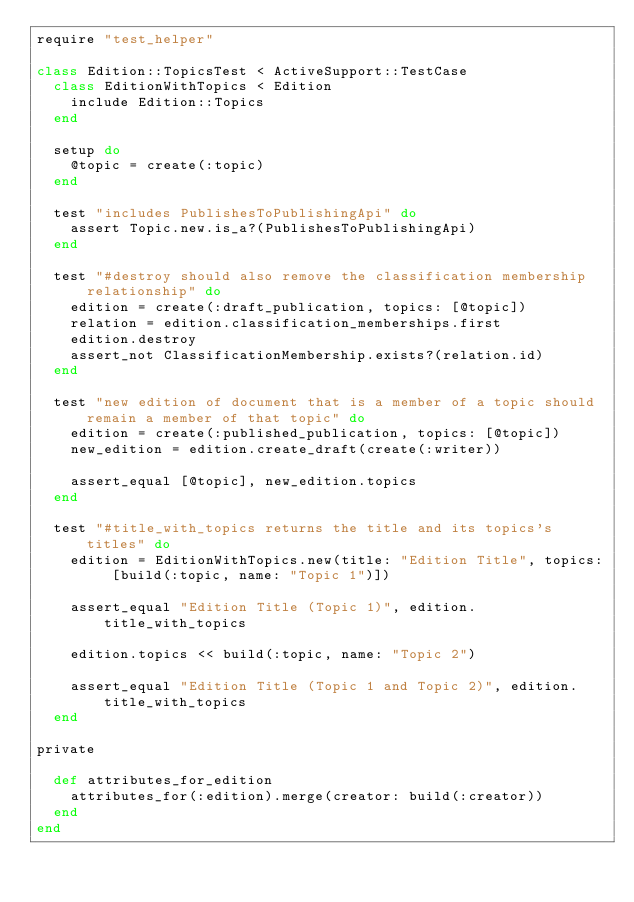<code> <loc_0><loc_0><loc_500><loc_500><_Ruby_>require "test_helper"

class Edition::TopicsTest < ActiveSupport::TestCase
  class EditionWithTopics < Edition
    include Edition::Topics
  end

  setup do
    @topic = create(:topic)
  end

  test "includes PublishesToPublishingApi" do
    assert Topic.new.is_a?(PublishesToPublishingApi)
  end

  test "#destroy should also remove the classification membership relationship" do
    edition = create(:draft_publication, topics: [@topic])
    relation = edition.classification_memberships.first
    edition.destroy
    assert_not ClassificationMembership.exists?(relation.id)
  end

  test "new edition of document that is a member of a topic should remain a member of that topic" do
    edition = create(:published_publication, topics: [@topic])
    new_edition = edition.create_draft(create(:writer))

    assert_equal [@topic], new_edition.topics
  end

  test "#title_with_topics returns the title and its topics's titles" do
    edition = EditionWithTopics.new(title: "Edition Title", topics: [build(:topic, name: "Topic 1")])

    assert_equal "Edition Title (Topic 1)", edition.title_with_topics

    edition.topics << build(:topic, name: "Topic 2")

    assert_equal "Edition Title (Topic 1 and Topic 2)", edition.title_with_topics
  end

private

  def attributes_for_edition
    attributes_for(:edition).merge(creator: build(:creator))
  end
end
</code> 